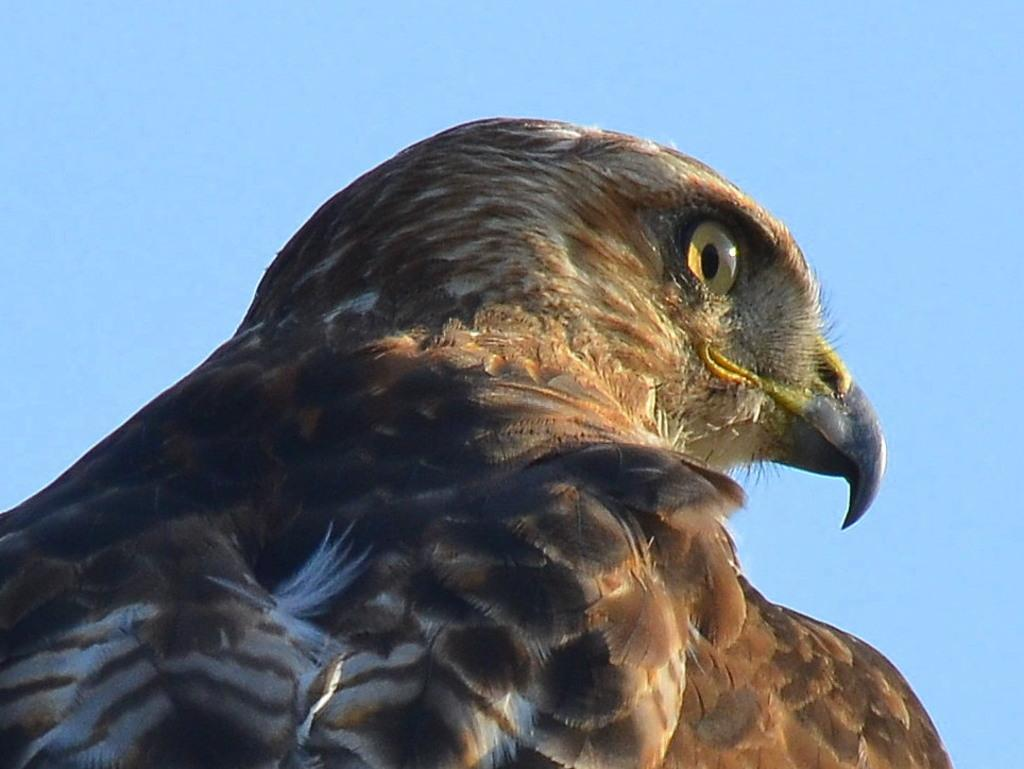What type of animal can be seen in the picture? There is a bird in the picture. What can be seen in the background of the picture? The sky is visible in the background of the picture. Can you see any goldfish swimming in the river in the picture? There is no river or goldfish present in the picture; it features a bird and the sky. 